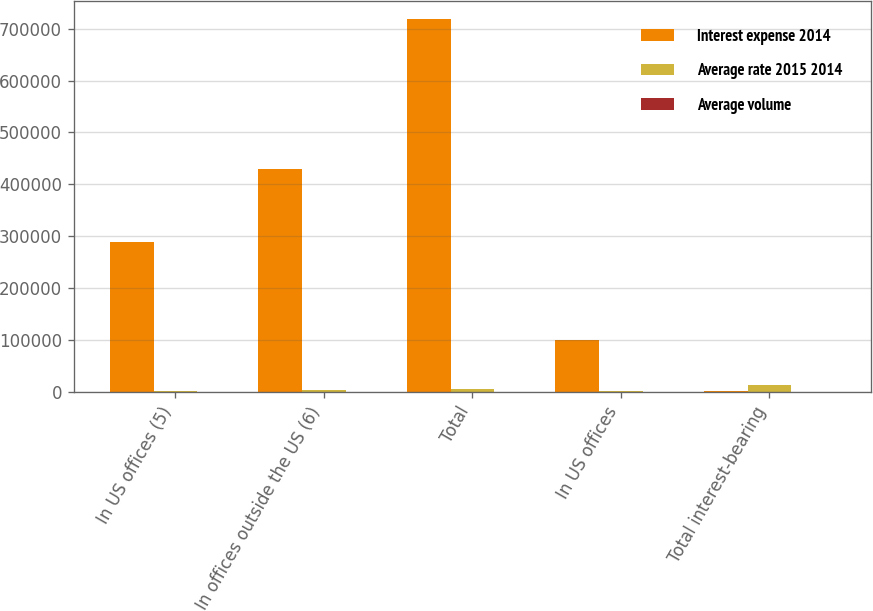<chart> <loc_0><loc_0><loc_500><loc_500><stacked_bar_chart><ecel><fcel>In US offices (5)<fcel>In offices outside the US (6)<fcel>Total<fcel>In US offices<fcel>Total interest-bearing<nl><fcel>Interest expense 2014<fcel>288817<fcel>429608<fcel>718425<fcel>100472<fcel>2650<nl><fcel>Average rate 2015 2014<fcel>1630<fcel>3670<fcel>5300<fcel>1024<fcel>12511<nl><fcel>Average volume<fcel>0.56<fcel>0.85<fcel>0.74<fcel>1.02<fcel>1.03<nl></chart> 